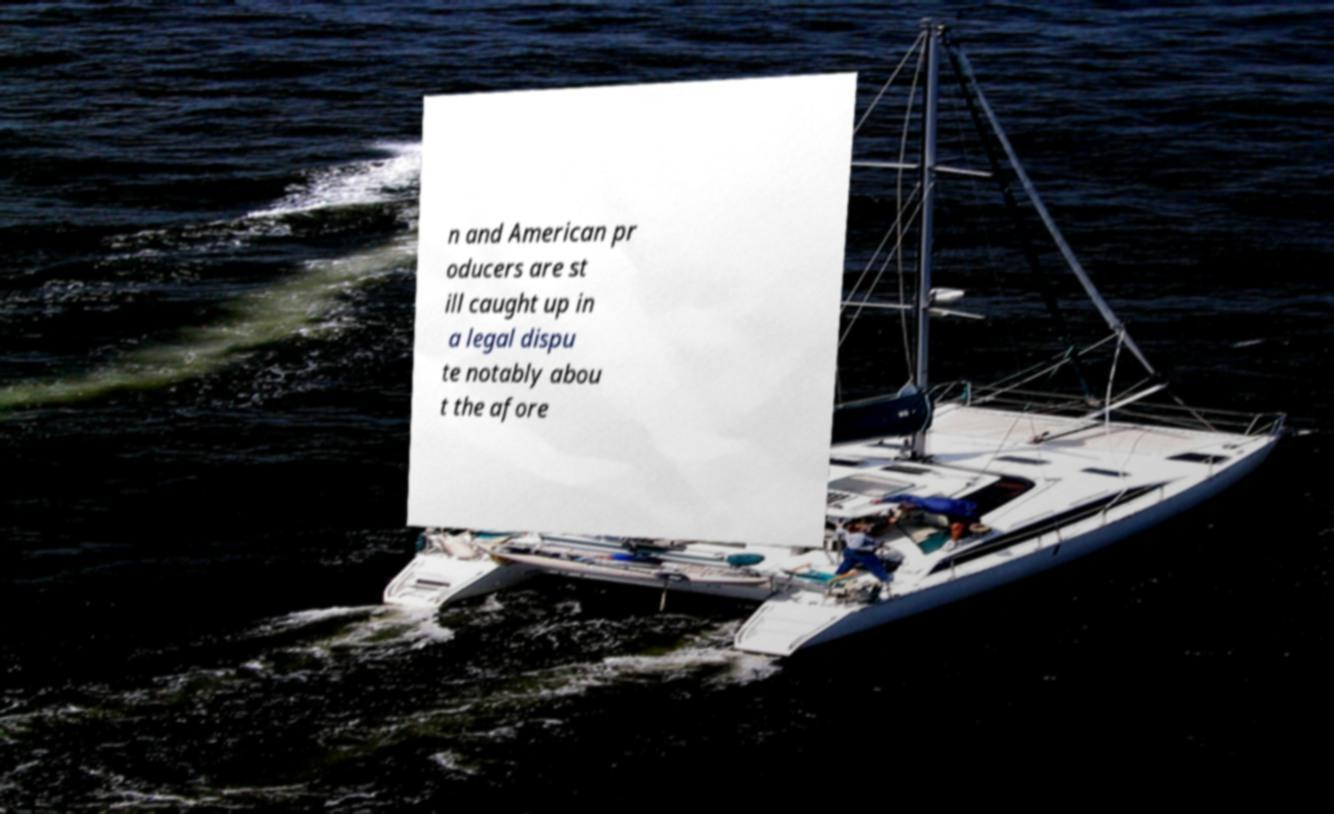Can you accurately transcribe the text from the provided image for me? n and American pr oducers are st ill caught up in a legal dispu te notably abou t the afore 